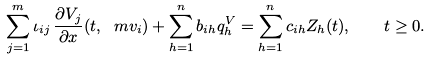Convert formula to latex. <formula><loc_0><loc_0><loc_500><loc_500>\sum _ { j = 1 } ^ { m } \iota _ { i j } \, \frac { \partial V _ { j } } { \partial x } ( t , \ m v _ { i } ) + \sum _ { h = 1 } ^ { n } b _ { i h } q ^ { V } _ { h } = \sum _ { h = 1 } ^ { n } c _ { i h } Z _ { h } ( t ) , \quad t \geq 0 .</formula> 